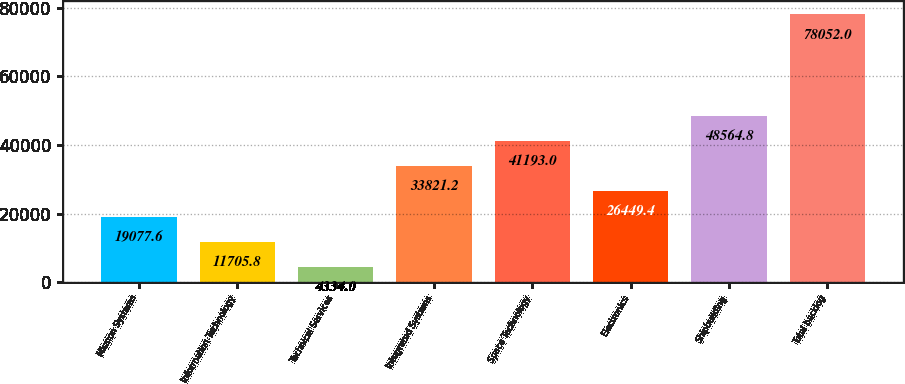<chart> <loc_0><loc_0><loc_500><loc_500><bar_chart><fcel>Mission Systems<fcel>Information Technology<fcel>Technical Services<fcel>Integrated Systems<fcel>Space Technology<fcel>Electronics<fcel>Shipbuilding<fcel>Total backlog<nl><fcel>19077.6<fcel>11705.8<fcel>4334<fcel>33821.2<fcel>41193<fcel>26449.4<fcel>48564.8<fcel>78052<nl></chart> 